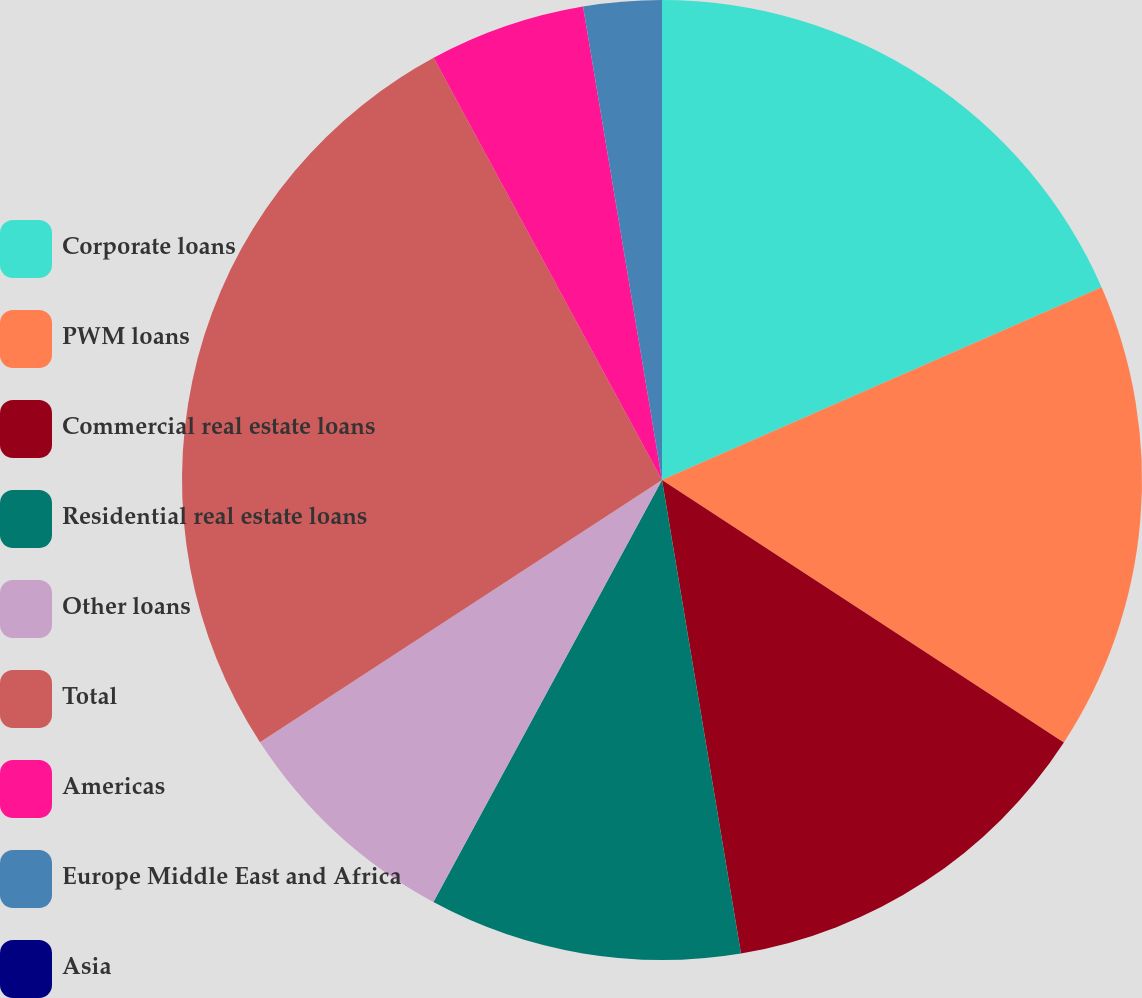Convert chart to OTSL. <chart><loc_0><loc_0><loc_500><loc_500><pie_chart><fcel>Corporate loans<fcel>PWM loans<fcel>Commercial real estate loans<fcel>Residential real estate loans<fcel>Other loans<fcel>Total<fcel>Americas<fcel>Europe Middle East and Africa<fcel>Asia<nl><fcel>18.42%<fcel>15.79%<fcel>13.16%<fcel>10.53%<fcel>7.9%<fcel>26.31%<fcel>5.26%<fcel>2.63%<fcel>0.0%<nl></chart> 